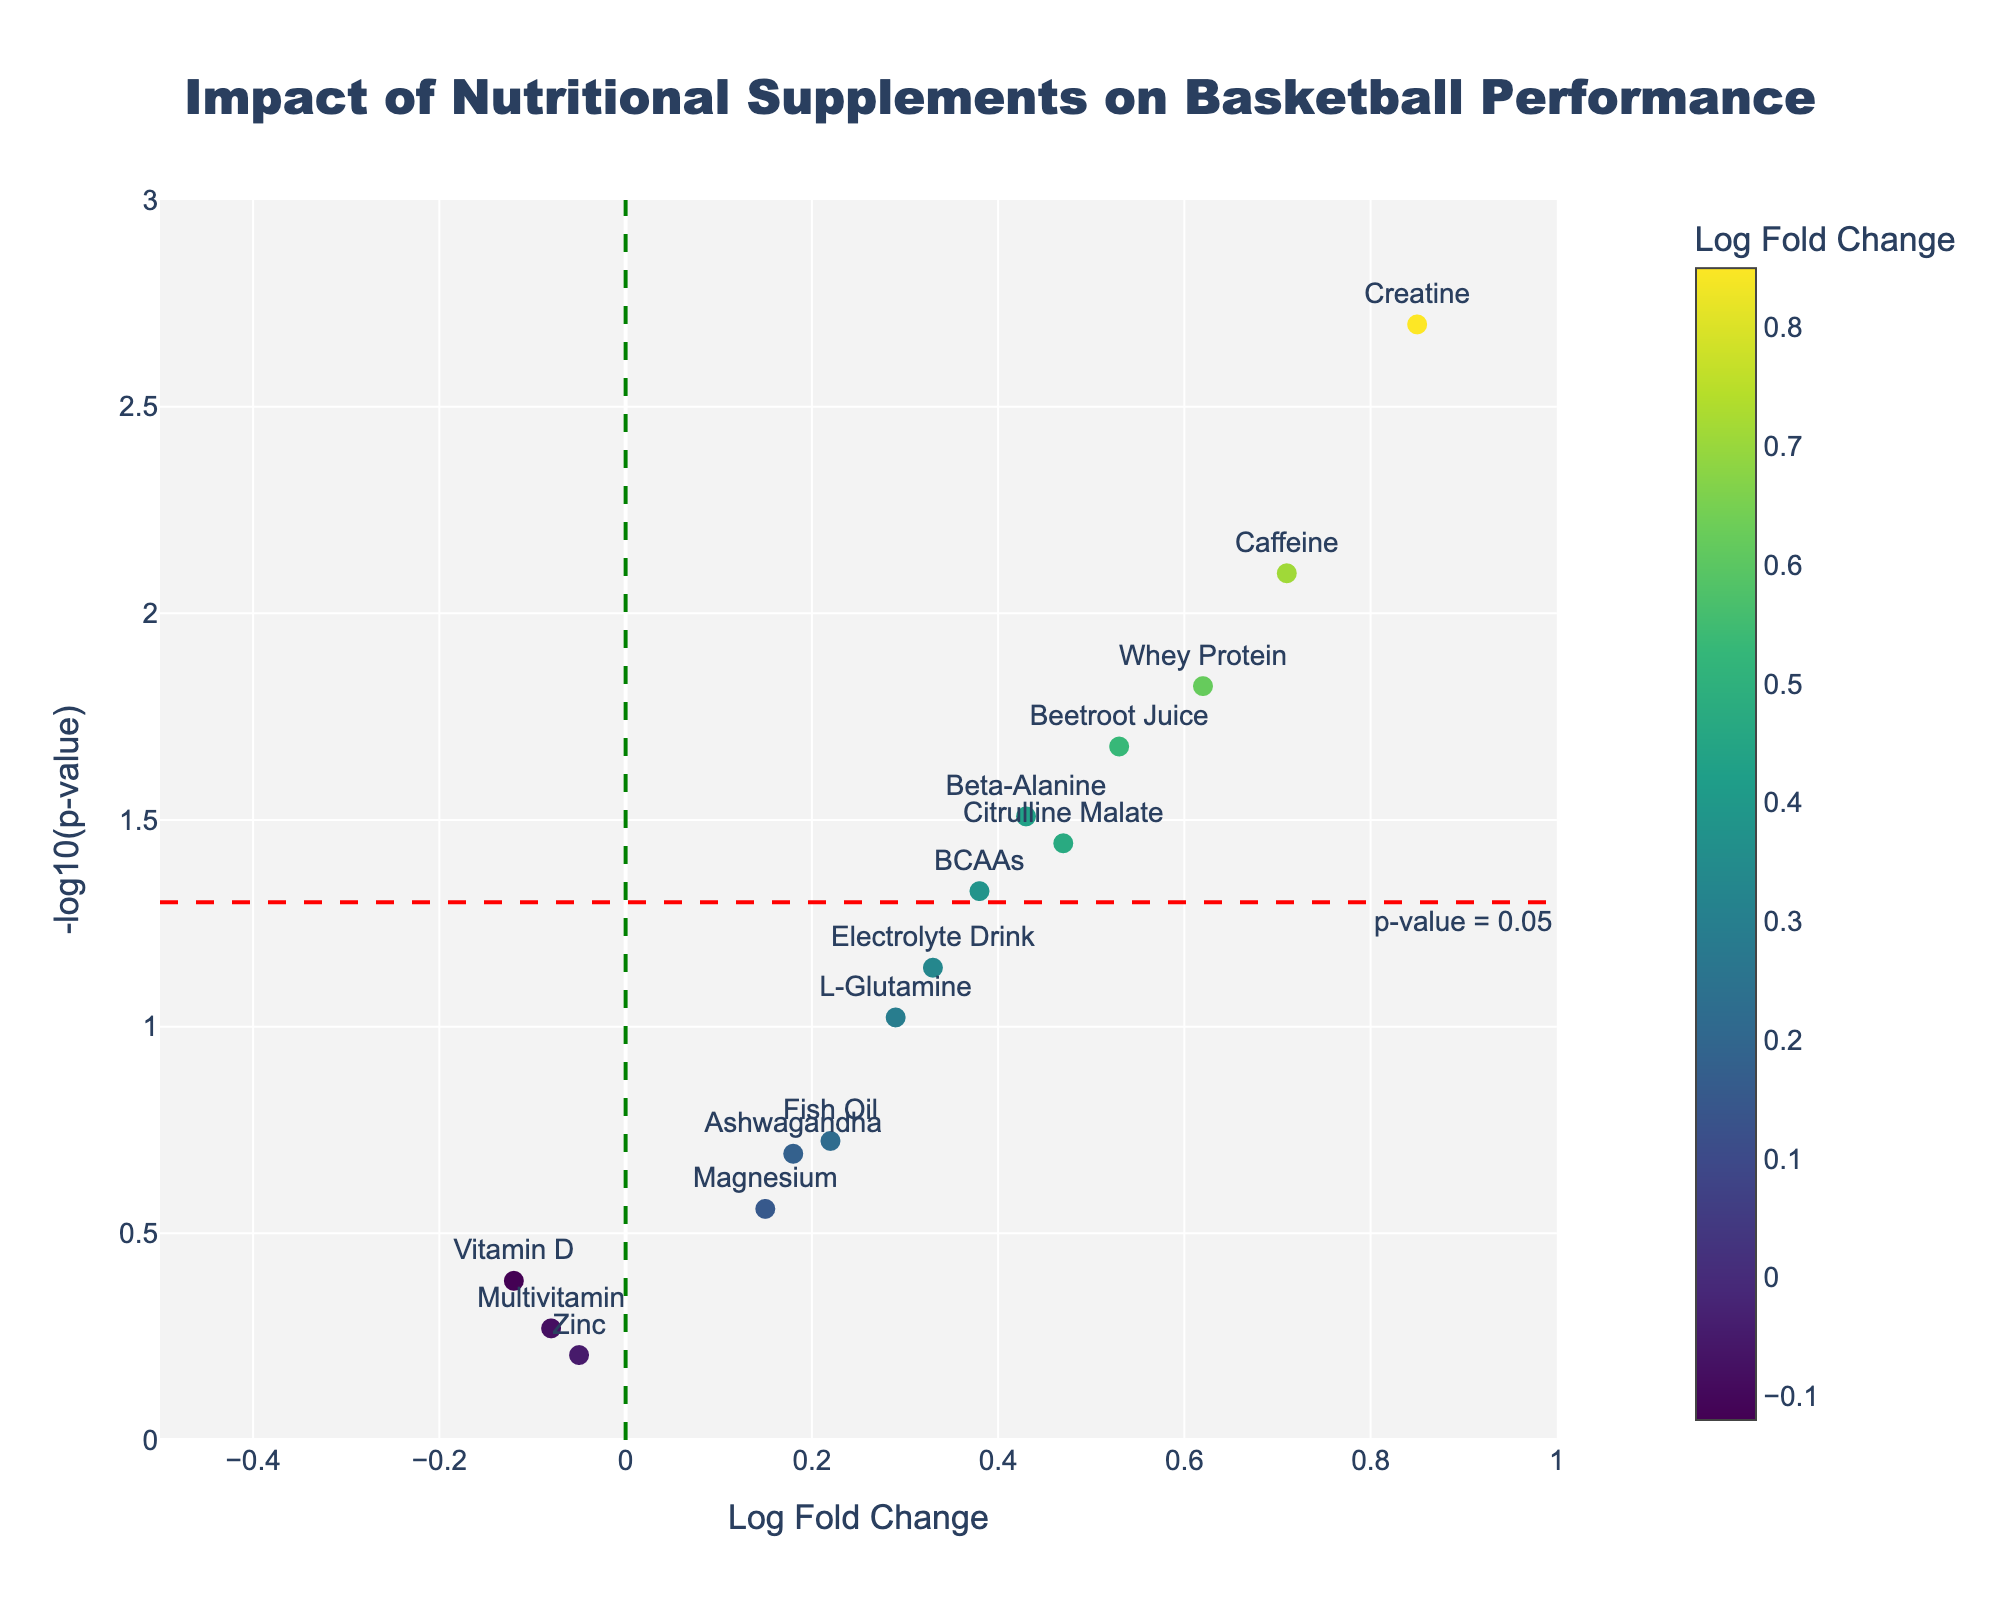What is the title of the plot? The title is usually prominently displayed at the top of the figure. In this case, the title is centered and reads "Impact of Nutritional Supplements on Basketball Performance".
Answer: Impact of Nutritional Supplements on Basketball Performance What does the x-axis represent? The x-axis is labeled with "Log Fold Change" which indicates the log fold change in performance metrics due to the nutritional supplements.
Answer: Log Fold Change What does the y-axis represent? The y-axis is labeled with "-log10(p-value)" which means it shows the negative logarithm (base 10) of the p-values.
Answer: -log10(p-value) Which supplement has the highest log fold change? To find the supplement with the highest log fold change, look for the data point farthest to the right on the x-axis. In this case, it's "Creatine" with a log fold change of 0.85.
Answer: Creatine Which supplement has the lowest p-value? The lowest p-value corresponds to the highest -log10(p-value) on the y-axis. Thus, the supplement at the highest position on the y-axis is "Creatine".
Answer: Creatine How many supplements have a p-value less than 0.05? The red horizontal line marks the threshold of p-value = 0.05. Count the data points above this line to get the number of supplements with p-values less than 0.05. There are 7 such supplements: Creatine, Whey Protein, Beta-Alanine, Caffeine, BCAAs, Beetroot Juice, and Citrulline Malate.
Answer: 7 Which supplement has the closest p-value to 0.05 but greater than it? Look for the data point just below the red horizontal line. The closest above but near the line would be "L-Glutamine" with a certain p-value not far off from 0.05.
Answer: L-Glutamine Are there any supplements that show a negative log fold change? If yes, which ones? To find supplements with negative log fold change, look for data points on the left side of the vertical green dashed line. The supplements with negative log fold changes are "Vitamin D", "Zinc", and "Multivitamin".
Answer: Vitamin D, Zinc, Multivitamin What is the fold change and p-value for Beetroot Juice? By examining the scatter points and associated hover text or labels, find the data point labeled "Beetroot Juice". Its log fold change is 0.53 and the p-value is 0.021.
Answer: Log fold change: 0.53, P-value: 0.021 Compare the effectiveness of Beetroot Juice and Caffeine based on the log fold change. Which one was more effective? Compare the log fold changes of "Beetroot Juice" (0.53) and "Caffeine" (0.71). Since 0.71 > 0.53, "Caffeine" is more effective than "Beetroot Juice" based on log fold change.
Answer: Caffeine 